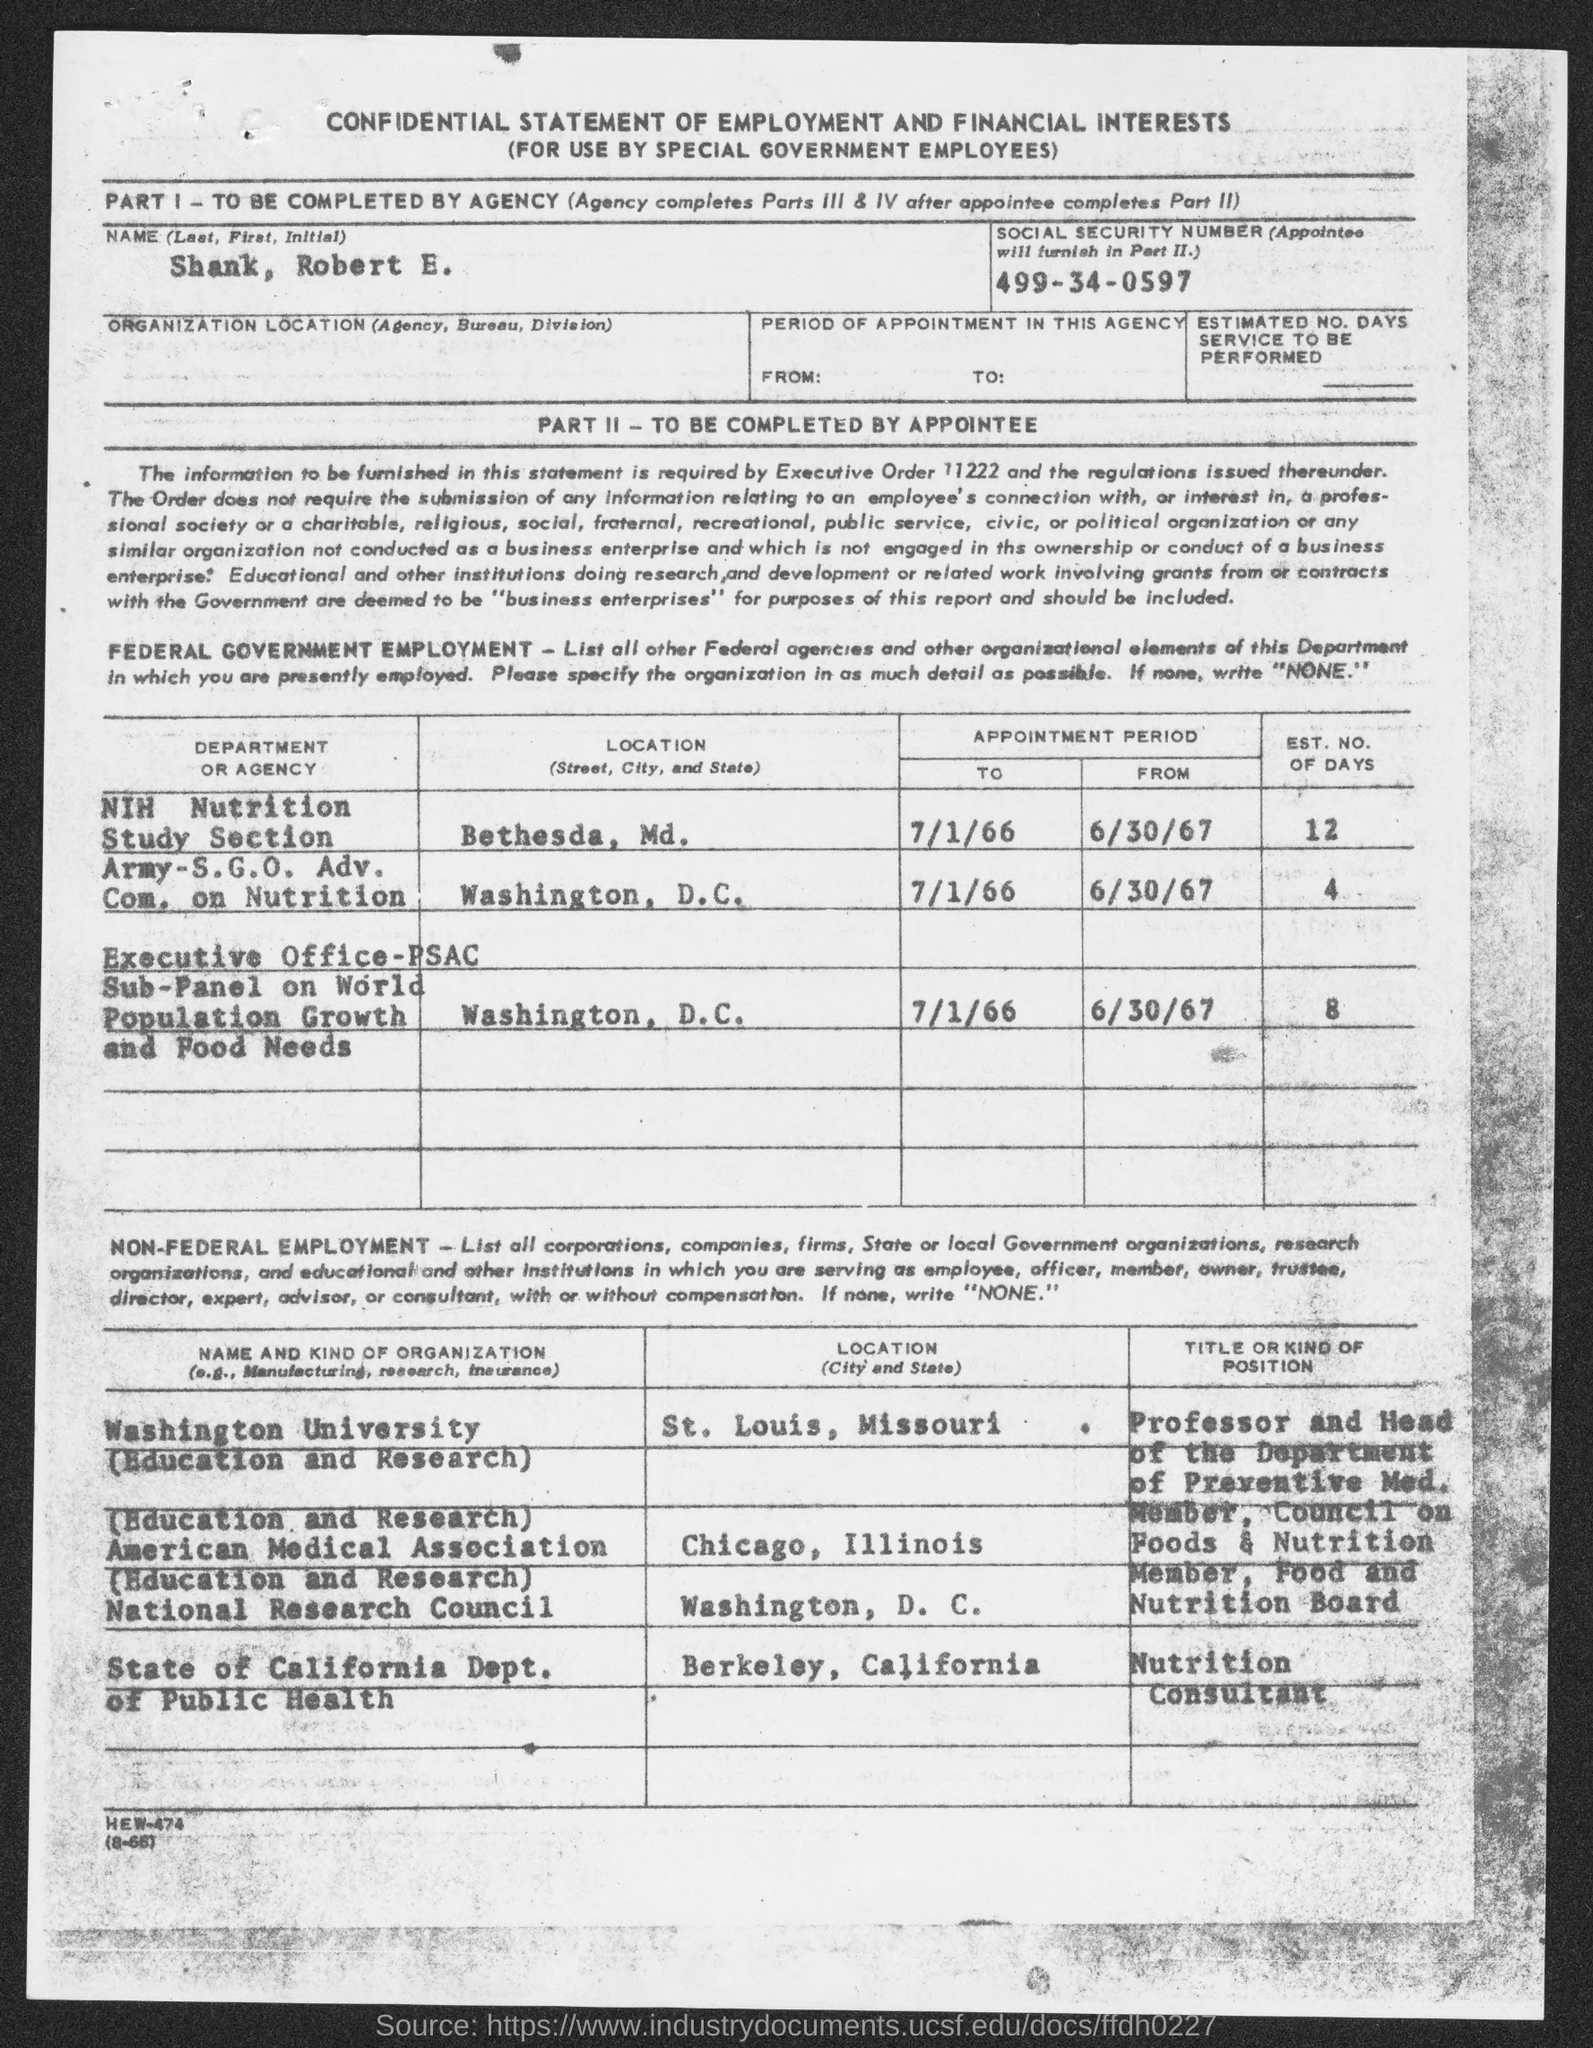What is the document title?
Make the answer very short. CONFIDENTIAL STATEMENT OF EMPLOYMENT AND FINANCIAL INTERESTS. What is the name given?
Ensure brevity in your answer.  Shank, Robert E. Where is the location of NIH Nutrition Study Section?
Provide a succinct answer. Bethesda, Md. What is the EST. NO. OF DAYS corresponding to Population Growth and Food Needs?
Keep it short and to the point. 8. What is the title or kind of position in State of California Dept. of Public Health?
Provide a short and direct response. Nutrition Consultant. 